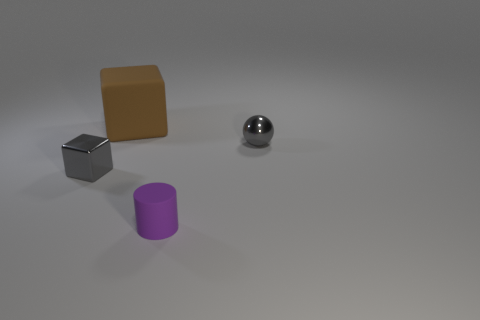What is the shape of the metallic thing that is the same color as the tiny ball?
Ensure brevity in your answer.  Cube. How many balls have the same material as the large cube?
Your answer should be compact. 0. The big rubber thing has what color?
Offer a terse response. Brown. Does the gray shiny thing in front of the gray shiny sphere have the same shape as the tiny purple rubber thing that is to the left of the gray sphere?
Give a very brief answer. No. What is the color of the tiny object that is to the left of the brown cube?
Keep it short and to the point. Gray. Is the number of small gray shiny things in front of the tiny metal block less than the number of gray metallic cubes that are to the left of the tiny matte cylinder?
Offer a very short reply. Yes. How many other objects are there of the same material as the small cylinder?
Make the answer very short. 1. Are the tiny purple cylinder and the big brown object made of the same material?
Offer a terse response. Yes. What number of other things are there of the same size as the metal sphere?
Your answer should be very brief. 2. There is a cube that is on the right side of the gray thing to the left of the small rubber thing; what size is it?
Provide a succinct answer. Large. 